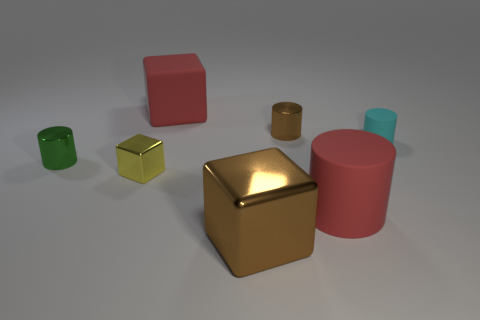Subtract all cyan cylinders. How many cylinders are left? 3 Subtract all large red rubber cylinders. How many cylinders are left? 3 Subtract all yellow cylinders. Subtract all gray cubes. How many cylinders are left? 4 Add 2 yellow things. How many objects exist? 9 Subtract all cylinders. How many objects are left? 3 Add 1 large red matte cylinders. How many large red matte cylinders are left? 2 Add 1 brown metal cubes. How many brown metal cubes exist? 2 Subtract 0 purple cubes. How many objects are left? 7 Subtract all small green metallic objects. Subtract all big shiny blocks. How many objects are left? 5 